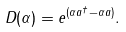Convert formula to latex. <formula><loc_0><loc_0><loc_500><loc_500>D ( \alpha ) = e ^ { ( \alpha a ^ { \dag } - \alpha a ) } .</formula> 